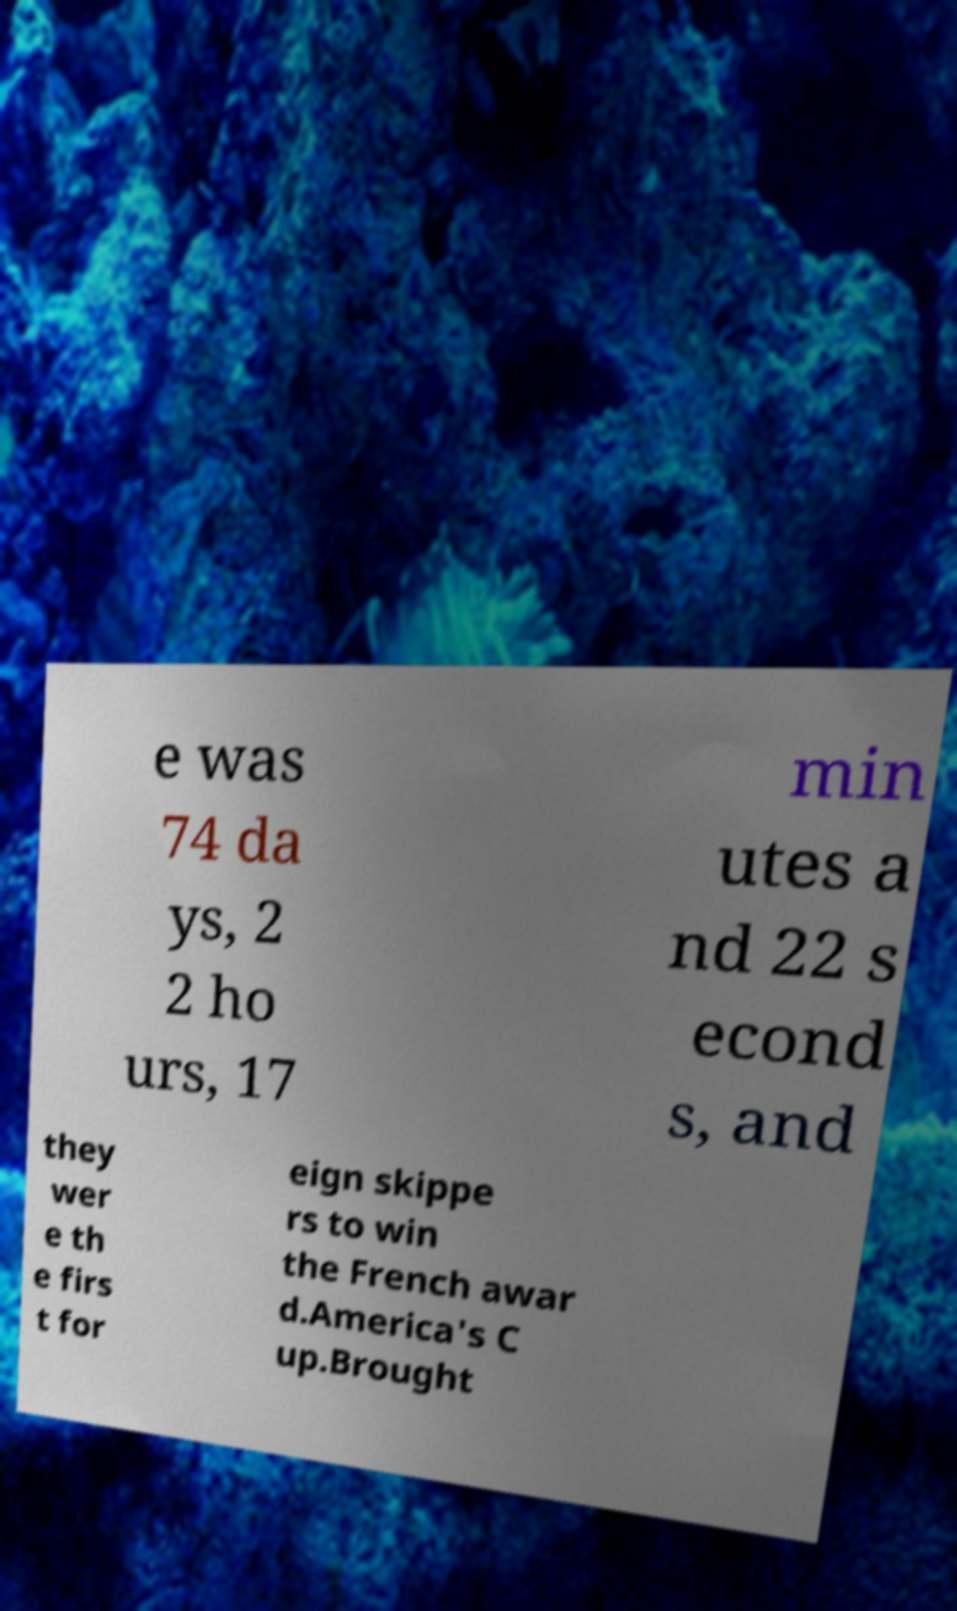There's text embedded in this image that I need extracted. Can you transcribe it verbatim? e was 74 da ys, 2 2 ho urs, 17 min utes a nd 22 s econd s, and they wer e th e firs t for eign skippe rs to win the French awar d.America's C up.Brought 